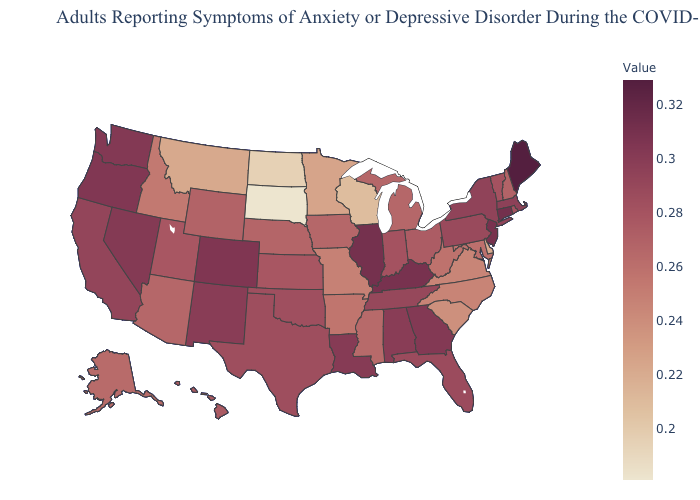Does Hawaii have a lower value than Montana?
Keep it brief. No. Among the states that border California , does Oregon have the lowest value?
Concise answer only. No. Does Washington have a higher value than Oklahoma?
Answer briefly. Yes. Does New York have a lower value than Connecticut?
Answer briefly. Yes. 